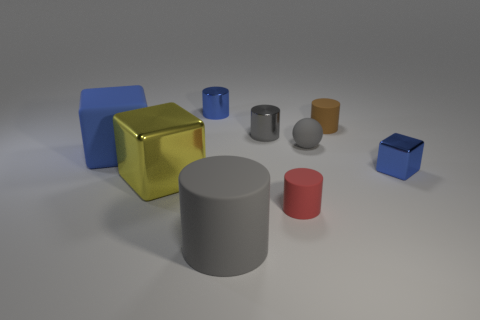What is the size of the rubber object that is the same color as the tiny rubber ball?
Your response must be concise. Large. Is there anything else that has the same color as the large metallic cube?
Provide a short and direct response. No. Is the number of tiny blue things that are left of the small ball greater than the number of big green matte balls?
Keep it short and to the point. Yes. What material is the tiny red object?
Your answer should be very brief. Rubber. What number of brown cylinders are the same size as the blue cylinder?
Provide a succinct answer. 1. Is the number of big matte cylinders behind the large gray cylinder the same as the number of metallic objects that are right of the gray shiny object?
Provide a succinct answer. No. Is the material of the big yellow thing the same as the tiny blue cylinder?
Ensure brevity in your answer.  Yes. Is there a brown cylinder that is behind the tiny gray thing to the left of the tiny gray rubber sphere?
Your response must be concise. Yes. Is there a large purple rubber object that has the same shape as the brown thing?
Make the answer very short. No. Is the tiny shiny block the same color as the large matte block?
Your answer should be very brief. Yes. 